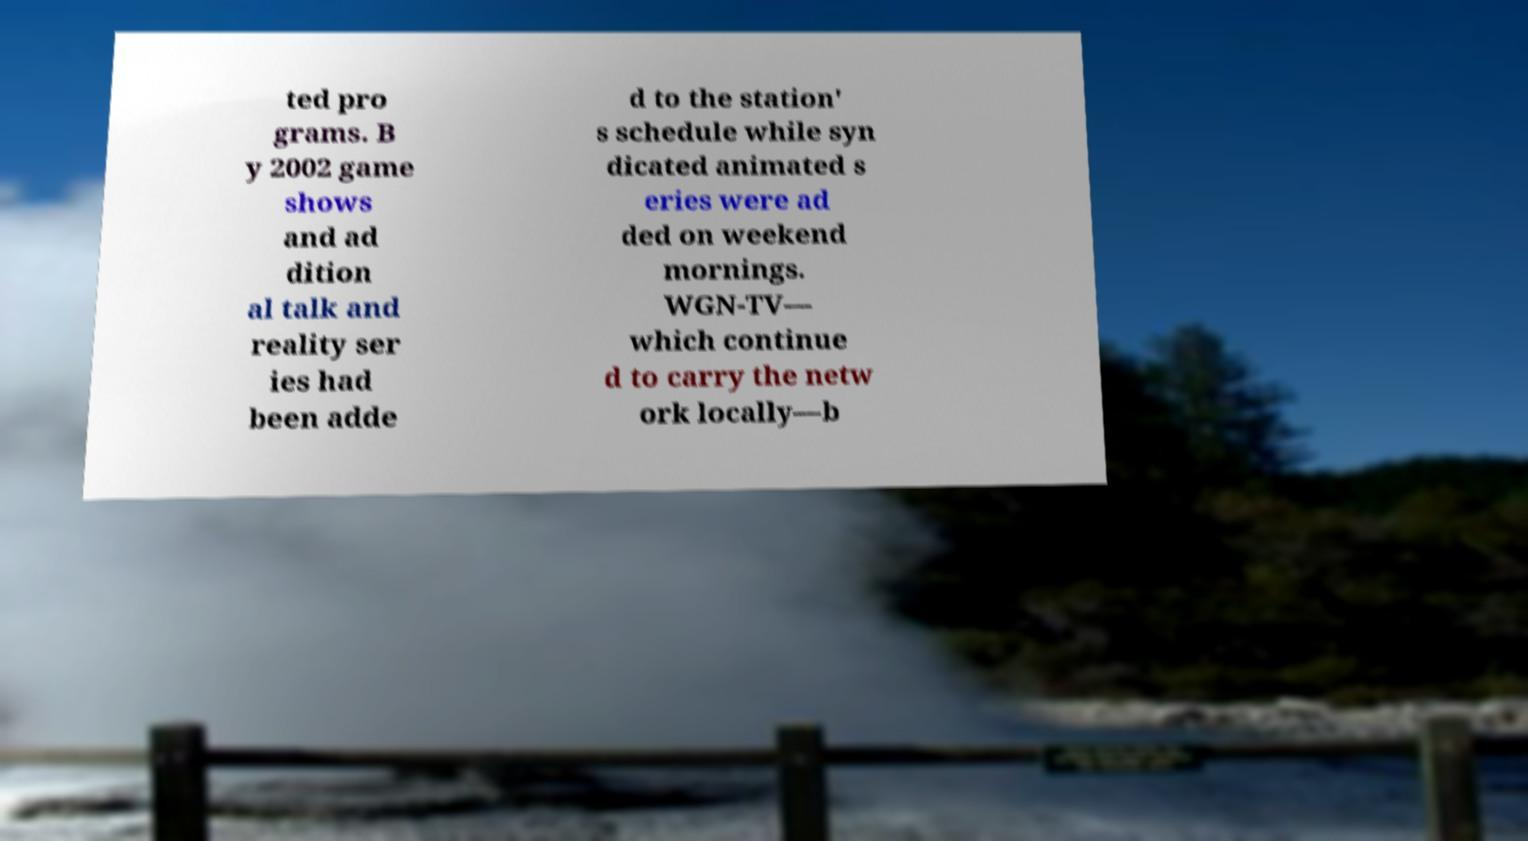For documentation purposes, I need the text within this image transcribed. Could you provide that? ted pro grams. B y 2002 game shows and ad dition al talk and reality ser ies had been adde d to the station' s schedule while syn dicated animated s eries were ad ded on weekend mornings. WGN-TV— which continue d to carry the netw ork locally—b 